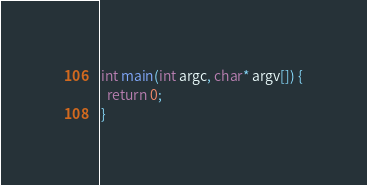Convert code to text. <code><loc_0><loc_0><loc_500><loc_500><_C++_>
int main(int argc, char* argv[]) {
  return 0;
}
</code> 